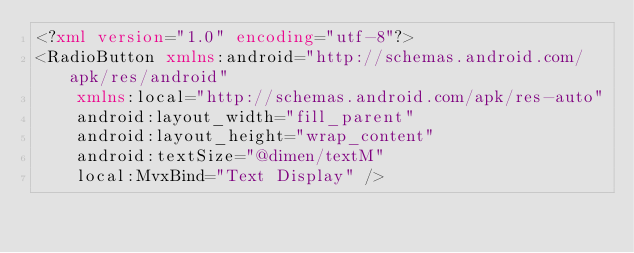<code> <loc_0><loc_0><loc_500><loc_500><_XML_><?xml version="1.0" encoding="utf-8"?>
<RadioButton xmlns:android="http://schemas.android.com/apk/res/android"
    xmlns:local="http://schemas.android.com/apk/res-auto"
    android:layout_width="fill_parent"
    android:layout_height="wrap_content"
    android:textSize="@dimen/textM"
    local:MvxBind="Text Display" /></code> 